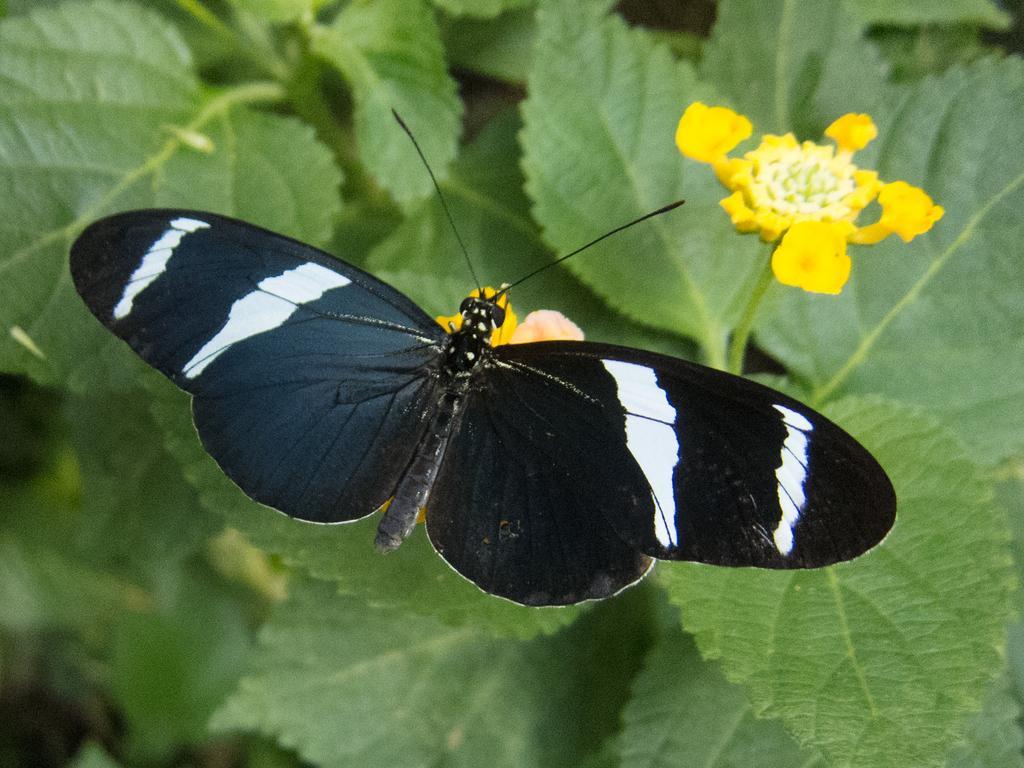In one or two sentences, can you explain what this image depicts? In this image I can see the butterfly on the flower. The butterfly is in white and black color. And I can see the yellow and white color flowers to the plants. 